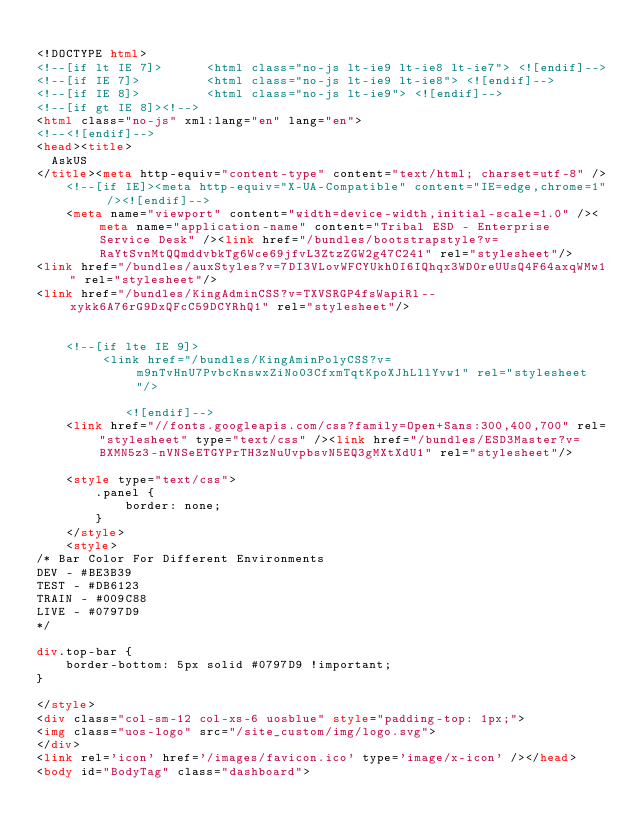Convert code to text. <code><loc_0><loc_0><loc_500><loc_500><_HTML_>
<!DOCTYPE html>
<!--[if lt IE 7]>      <html class="no-js lt-ie9 lt-ie8 lt-ie7"> <![endif]-->
<!--[if IE 7]>         <html class="no-js lt-ie9 lt-ie8"> <![endif]-->
<!--[if IE 8]>         <html class="no-js lt-ie9"> <![endif]-->
<!--[if gt IE 8]><!-->
<html class="no-js" xml:lang="en" lang="en">
<!--<![endif]-->
<head><title>
	AskUS
</title><meta http-equiv="content-type" content="text/html; charset=utf-8" />
    <!--[if IE]><meta http-equiv="X-UA-Compatible" content="IE=edge,chrome=1" /><![endif]-->
    <meta name="viewport" content="width=device-width,initial-scale=1.0" /><meta name="application-name" content="Tribal ESD - Enterprise Service Desk" /><link href="/bundles/bootstrapstyle?v=RaYtSvnMtQQmddvbkTg6Wce69jfvL3ZtzZGW2g47C241" rel="stylesheet"/>
<link href="/bundles/auxStyles?v=7DI3VLovWFCYUkhOI6IQhqx3WD0reUUsQ4F64axqWMw1" rel="stylesheet"/>
<link href="/bundles/KingAdminCSS?v=TXVSRGP4fsWapiRl--xykk6A76rG9DxQFcC59DCYRhQ1" rel="stylesheet"/>


    <!--[if lte IE 9]>
         <link href="/bundles/KingAminPolyCSS?v=m9nTvHnU7PvbcKnswxZiNo03CfxmTqtKpoXJhLllYvw1" rel="stylesheet"/>

            <![endif]-->
    <link href="//fonts.googleapis.com/css?family=Open+Sans:300,400,700" rel="stylesheet" type="text/css" /><link href="/bundles/ESD3Master?v=BXMN5z3-nVNSeETGYPrTH3zNuUvpbsvN5EQ3gMXtXdU1" rel="stylesheet"/>

    <style type="text/css">
        .panel {
            border: none;
        }
    </style>
    <style>
/* Bar Color For Different Environments 
DEV - #BE3B39
TEST - #DB6123
TRAIN - #009C88
LIVE - #0797D9
*/

div.top-bar {
    border-bottom: 5px solid #0797D9 !important;
}

</style>
<div class="col-sm-12 col-xs-6 uosblue" style="padding-top: 1px;">
<img class="uos-logo" src="/site_custom/img/logo.svg">
</div>
<link rel='icon' href='/images/favicon.ico' type='image/x-icon' /></head>
<body id="BodyTag" class="dashboard"></code> 